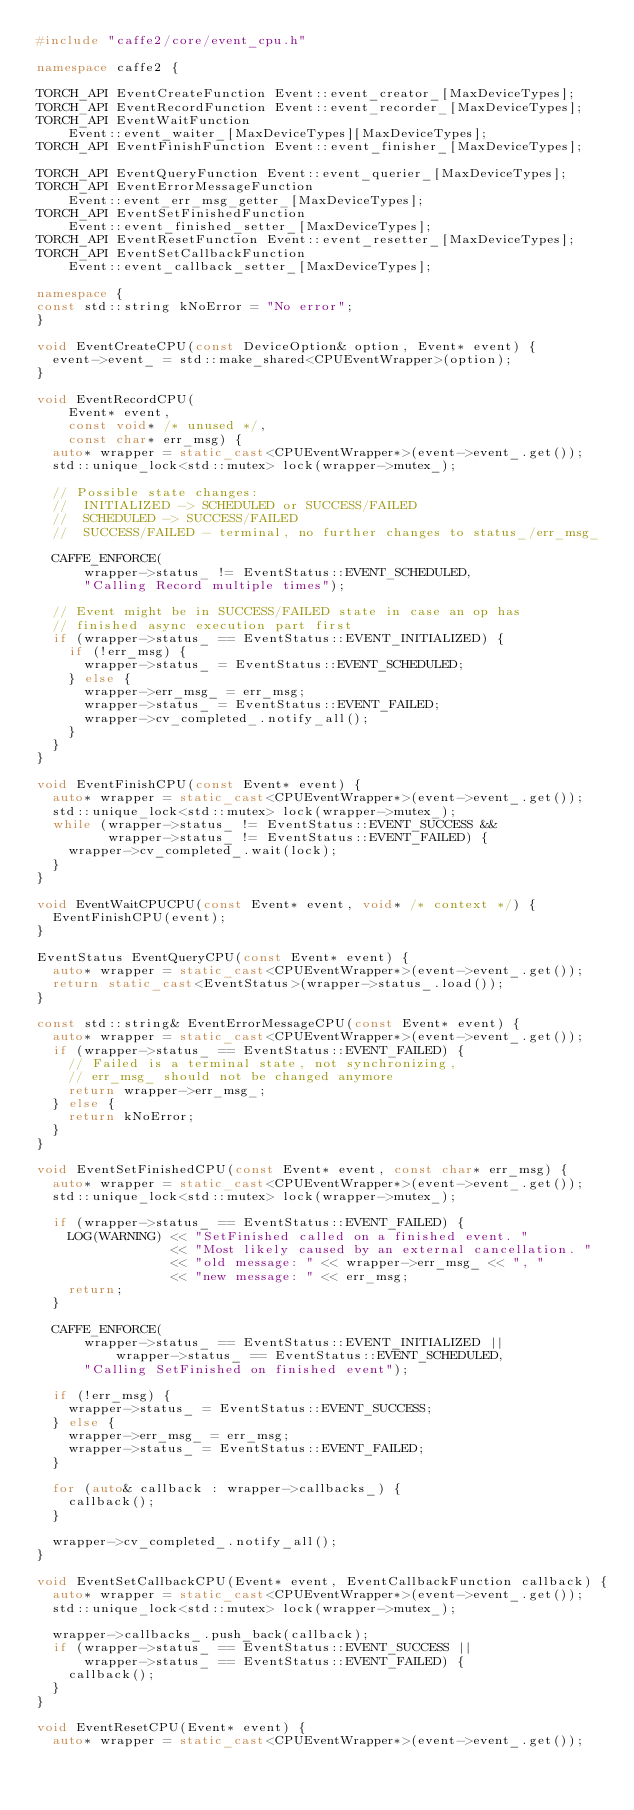Convert code to text. <code><loc_0><loc_0><loc_500><loc_500><_C++_>#include "caffe2/core/event_cpu.h"

namespace caffe2 {

TORCH_API EventCreateFunction Event::event_creator_[MaxDeviceTypes];
TORCH_API EventRecordFunction Event::event_recorder_[MaxDeviceTypes];
TORCH_API EventWaitFunction
    Event::event_waiter_[MaxDeviceTypes][MaxDeviceTypes];
TORCH_API EventFinishFunction Event::event_finisher_[MaxDeviceTypes];

TORCH_API EventQueryFunction Event::event_querier_[MaxDeviceTypes];
TORCH_API EventErrorMessageFunction
    Event::event_err_msg_getter_[MaxDeviceTypes];
TORCH_API EventSetFinishedFunction
    Event::event_finished_setter_[MaxDeviceTypes];
TORCH_API EventResetFunction Event::event_resetter_[MaxDeviceTypes];
TORCH_API EventSetCallbackFunction
    Event::event_callback_setter_[MaxDeviceTypes];

namespace {
const std::string kNoError = "No error";
}

void EventCreateCPU(const DeviceOption& option, Event* event) {
  event->event_ = std::make_shared<CPUEventWrapper>(option);
}

void EventRecordCPU(
    Event* event,
    const void* /* unused */,
    const char* err_msg) {
  auto* wrapper = static_cast<CPUEventWrapper*>(event->event_.get());
  std::unique_lock<std::mutex> lock(wrapper->mutex_);

  // Possible state changes:
  //  INITIALIZED -> SCHEDULED or SUCCESS/FAILED
  //  SCHEDULED -> SUCCESS/FAILED
  //  SUCCESS/FAILED - terminal, no further changes to status_/err_msg_

  CAFFE_ENFORCE(
      wrapper->status_ != EventStatus::EVENT_SCHEDULED,
      "Calling Record multiple times");

  // Event might be in SUCCESS/FAILED state in case an op has
  // finished async execution part first
  if (wrapper->status_ == EventStatus::EVENT_INITIALIZED) {
    if (!err_msg) {
      wrapper->status_ = EventStatus::EVENT_SCHEDULED;
    } else {
      wrapper->err_msg_ = err_msg;
      wrapper->status_ = EventStatus::EVENT_FAILED;
      wrapper->cv_completed_.notify_all();
    }
  }
}

void EventFinishCPU(const Event* event) {
  auto* wrapper = static_cast<CPUEventWrapper*>(event->event_.get());
  std::unique_lock<std::mutex> lock(wrapper->mutex_);
  while (wrapper->status_ != EventStatus::EVENT_SUCCESS &&
         wrapper->status_ != EventStatus::EVENT_FAILED) {
    wrapper->cv_completed_.wait(lock);
  }
}

void EventWaitCPUCPU(const Event* event, void* /* context */) {
  EventFinishCPU(event);
}

EventStatus EventQueryCPU(const Event* event) {
  auto* wrapper = static_cast<CPUEventWrapper*>(event->event_.get());
  return static_cast<EventStatus>(wrapper->status_.load());
}

const std::string& EventErrorMessageCPU(const Event* event) {
  auto* wrapper = static_cast<CPUEventWrapper*>(event->event_.get());
  if (wrapper->status_ == EventStatus::EVENT_FAILED) {
    // Failed is a terminal state, not synchronizing,
    // err_msg_ should not be changed anymore
    return wrapper->err_msg_;
  } else {
    return kNoError;
  }
}

void EventSetFinishedCPU(const Event* event, const char* err_msg) {
  auto* wrapper = static_cast<CPUEventWrapper*>(event->event_.get());
  std::unique_lock<std::mutex> lock(wrapper->mutex_);

  if (wrapper->status_ == EventStatus::EVENT_FAILED) {
    LOG(WARNING) << "SetFinished called on a finished event. "
                 << "Most likely caused by an external cancellation. "
                 << "old message: " << wrapper->err_msg_ << ", "
                 << "new message: " << err_msg;
    return;
  }

  CAFFE_ENFORCE(
      wrapper->status_ == EventStatus::EVENT_INITIALIZED ||
          wrapper->status_ == EventStatus::EVENT_SCHEDULED,
      "Calling SetFinished on finished event");

  if (!err_msg) {
    wrapper->status_ = EventStatus::EVENT_SUCCESS;
  } else {
    wrapper->err_msg_ = err_msg;
    wrapper->status_ = EventStatus::EVENT_FAILED;
  }

  for (auto& callback : wrapper->callbacks_) {
    callback();
  }

  wrapper->cv_completed_.notify_all();
}

void EventSetCallbackCPU(Event* event, EventCallbackFunction callback) {
  auto* wrapper = static_cast<CPUEventWrapper*>(event->event_.get());
  std::unique_lock<std::mutex> lock(wrapper->mutex_);

  wrapper->callbacks_.push_back(callback);
  if (wrapper->status_ == EventStatus::EVENT_SUCCESS ||
      wrapper->status_ == EventStatus::EVENT_FAILED) {
    callback();
  }
}

void EventResetCPU(Event* event) {
  auto* wrapper = static_cast<CPUEventWrapper*>(event->event_.get());</code> 